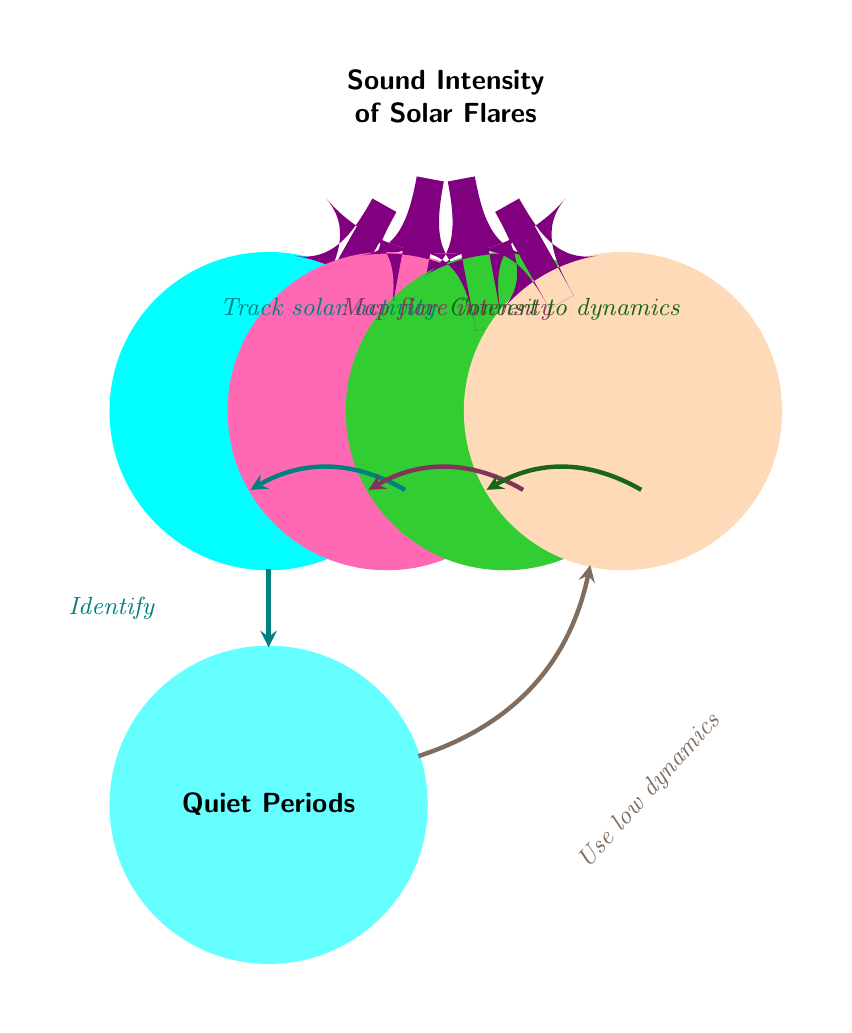What is the main focus of the diagram? The main focus of the diagram is indicated by the central node labeled "Sound Intensity of Solar Flares." This node represents the primary subject or theme being discussed in the mind map.
Answer: Sound Intensity of Solar Flares How many child nodes are connected to the central node? The central node has four child nodes branching from it: "Time Intervals," "Solar Flare Events," "Sound Intensity," and "Chiptune Notes." Counting these reveals that there are four child nodes in total.
Answer: 4 What color represents "Time Intervals"? The node labeled "Time Intervals" is colored chiptune cyan, as indicated by both the node color and the context within the diagram.
Answer: chiptune cyan What relationship is indicated between "Solar Flare Events" and "Sound Intensity"? The relationship between the two is shown through an arrow connecting the "Solar Flare Events" node to the "Sound Intensity" node. The arrow indicates that solar flare intensity is mapped to sound intensity.
Answer: Map flare intensity Which dynamics are used when there are "Quiet Periods"? The diagram specifies that during quiet periods, low dynamics are utilized for the chiptune notes, as shown by the arrow connecting "Quiet Periods" to "Chiptune Notes."
Answer: Low dynamics What is the purpose of identifying "Quiet Periods"? Identifying quiet periods allows for the differentiation of sound intensity levels and influences the dynamics used in chiptune compositions, linking back to the lower dynamics specified for these periods in the diagram. This explains how quiet periods affect sound representation.
Answer: Use low dynamics How do you convert sound intensity to chiptune dynamics? The conversion is depicted as a flow in the diagram, where sound intensity is mapped to chiptune notes, suggesting a process that translates intensity values into corresponding dynamic levels in chiptune music.
Answer: Convert to dynamics What action is taken to track solar activity over time? The diagram shows an arrow from "Time Intervals" to "Solar Flare Events," indicating that tracking solar activity involves observing or measuring solar flares during specified time intervals.
Answer: Track solar activity 